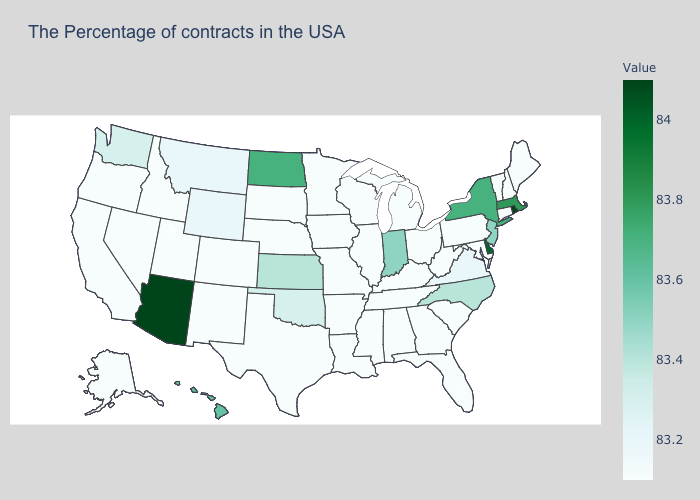Does Illinois have the highest value in the USA?
Concise answer only. No. Among the states that border Illinois , does Missouri have the lowest value?
Answer briefly. Yes. Is the legend a continuous bar?
Be succinct. Yes. Among the states that border Montana , which have the highest value?
Quick response, please. North Dakota. Among the states that border Illinois , which have the highest value?
Be succinct. Indiana. Among the states that border Vermont , which have the lowest value?
Be succinct. New Hampshire. Does New York have the highest value in the Northeast?
Quick response, please. No. 